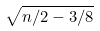Convert formula to latex. <formula><loc_0><loc_0><loc_500><loc_500>\sqrt { n / 2 - 3 / 8 }</formula> 